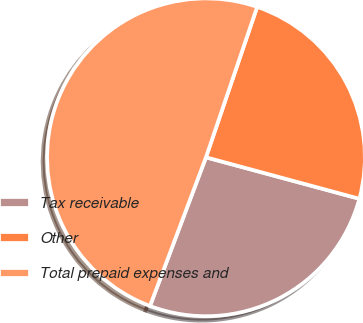Convert chart. <chart><loc_0><loc_0><loc_500><loc_500><pie_chart><fcel>Tax receivable<fcel>Other<fcel>Total prepaid expenses and<nl><fcel>26.53%<fcel>23.98%<fcel>49.49%<nl></chart> 